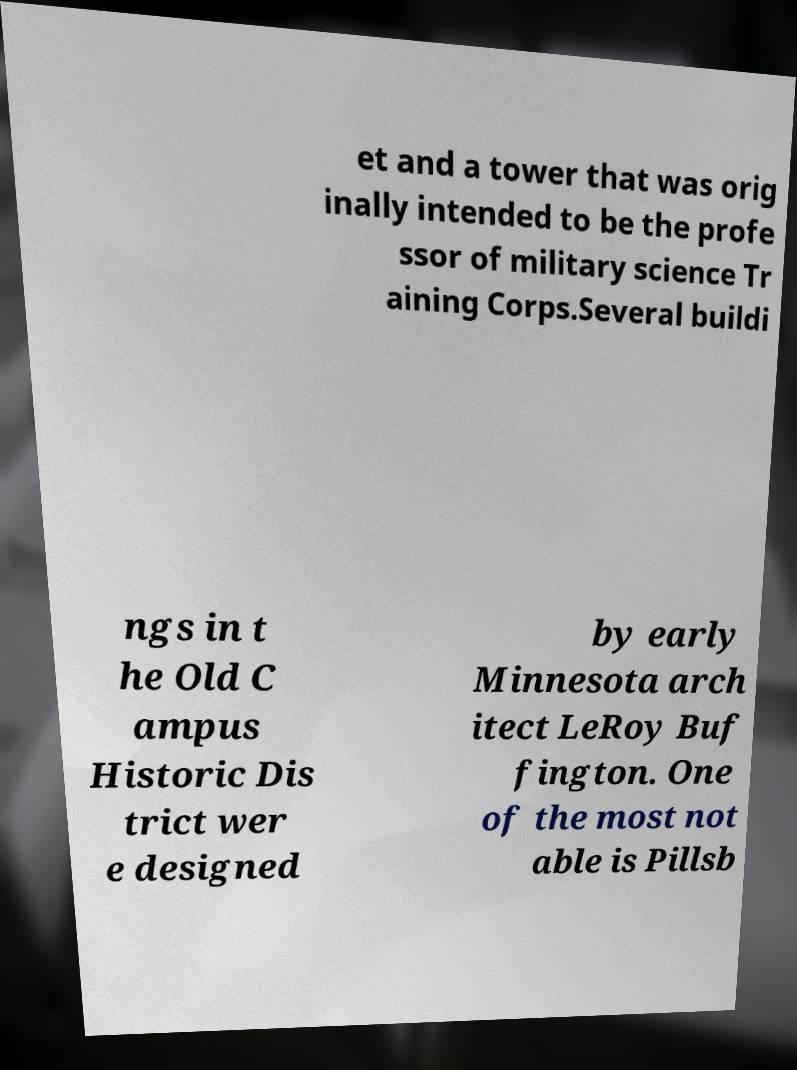Please read and relay the text visible in this image. What does it say? et and a tower that was orig inally intended to be the profe ssor of military science Tr aining Corps.Several buildi ngs in t he Old C ampus Historic Dis trict wer e designed by early Minnesota arch itect LeRoy Buf fington. One of the most not able is Pillsb 